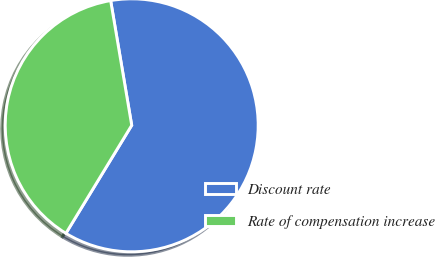Convert chart. <chart><loc_0><loc_0><loc_500><loc_500><pie_chart><fcel>Discount rate<fcel>Rate of compensation increase<nl><fcel>61.37%<fcel>38.63%<nl></chart> 